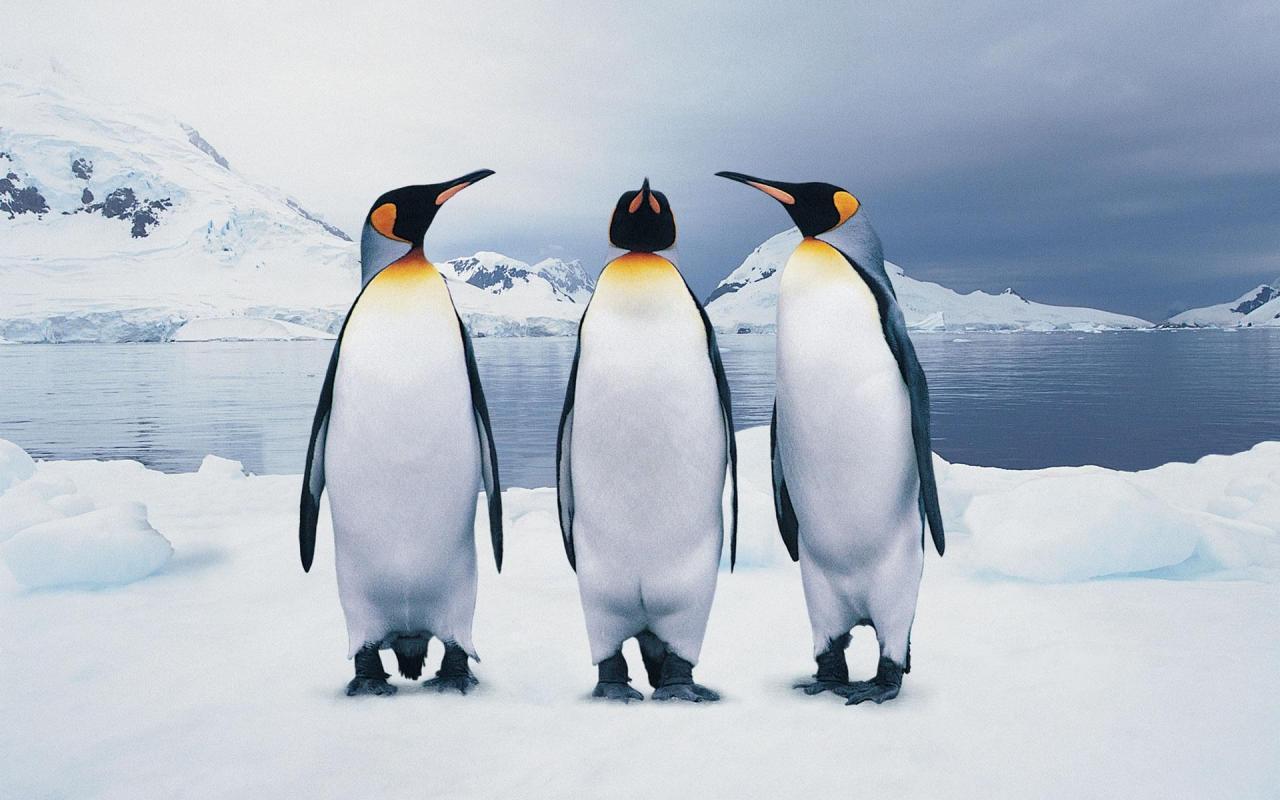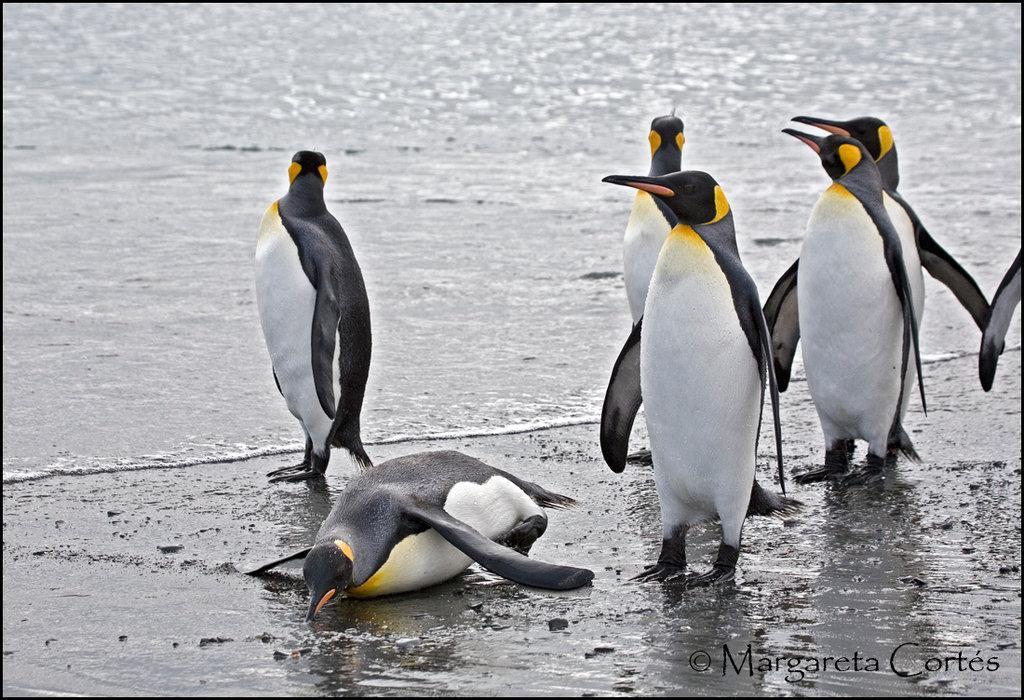The first image is the image on the left, the second image is the image on the right. For the images shown, is this caption "Atleast one picture with only one penguin." true? Answer yes or no. No. 